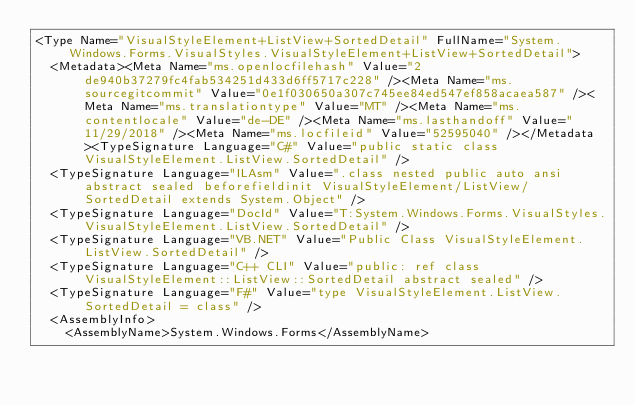<code> <loc_0><loc_0><loc_500><loc_500><_XML_><Type Name="VisualStyleElement+ListView+SortedDetail" FullName="System.Windows.Forms.VisualStyles.VisualStyleElement+ListView+SortedDetail">
  <Metadata><Meta Name="ms.openlocfilehash" Value="2de940b37279fc4fab534251d433d6ff5717c228" /><Meta Name="ms.sourcegitcommit" Value="0e1f030650a307c745ee84ed547ef858acaea587" /><Meta Name="ms.translationtype" Value="MT" /><Meta Name="ms.contentlocale" Value="de-DE" /><Meta Name="ms.lasthandoff" Value="11/29/2018" /><Meta Name="ms.locfileid" Value="52595040" /></Metadata><TypeSignature Language="C#" Value="public static class VisualStyleElement.ListView.SortedDetail" />
  <TypeSignature Language="ILAsm" Value=".class nested public auto ansi abstract sealed beforefieldinit VisualStyleElement/ListView/SortedDetail extends System.Object" />
  <TypeSignature Language="DocId" Value="T:System.Windows.Forms.VisualStyles.VisualStyleElement.ListView.SortedDetail" />
  <TypeSignature Language="VB.NET" Value="Public Class VisualStyleElement.ListView.SortedDetail" />
  <TypeSignature Language="C++ CLI" Value="public: ref class VisualStyleElement::ListView::SortedDetail abstract sealed" />
  <TypeSignature Language="F#" Value="type VisualStyleElement.ListView.SortedDetail = class" />
  <AssemblyInfo>
    <AssemblyName>System.Windows.Forms</AssemblyName></code> 